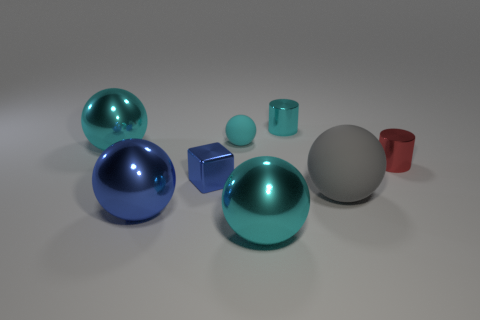Can you describe the lighting in this scene? The lighting in the image seems to be neutral and diffused, with no harsh shadows or bright highlights. This type of lighting tends to flatten the objects slightly but provides clear visibility of their colors and shapes, most likely coming from a simulated environment or a softly lit studio setup. 